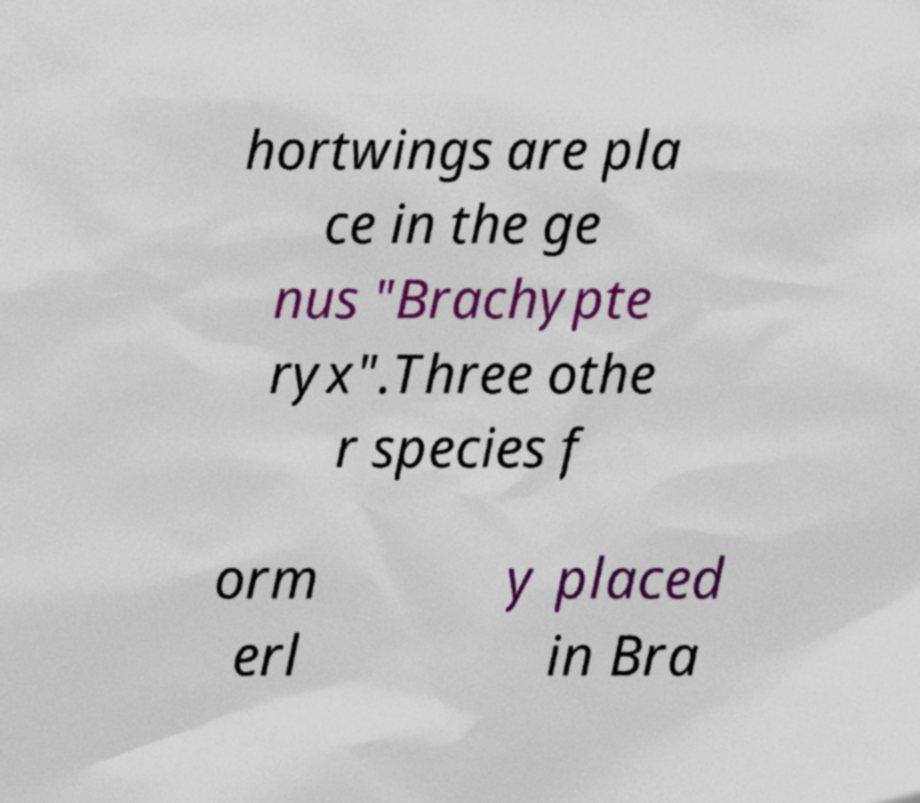What messages or text are displayed in this image? I need them in a readable, typed format. hortwings are pla ce in the ge nus "Brachypte ryx".Three othe r species f orm erl y placed in Bra 